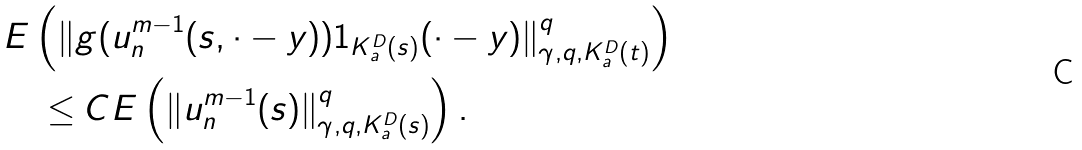<formula> <loc_0><loc_0><loc_500><loc_500>& E \left ( \| g ( u _ { n } ^ { m - 1 } ( s , \cdot - y ) ) 1 _ { K ^ { D } _ { a } ( s ) } ( \cdot - y ) \| ^ { q } _ { \gamma , q , K ^ { D } _ { a } ( t ) } \right ) \\ & \quad \leq C E \left ( \| u _ { n } ^ { m - 1 } ( s ) \| ^ { q } _ { \gamma , q , K ^ { D } _ { a } ( s ) } \right ) .</formula> 